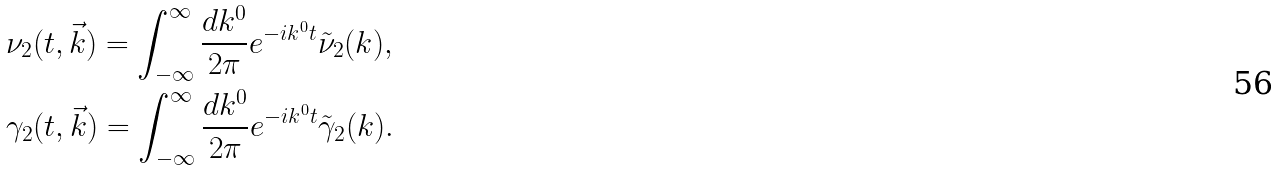Convert formula to latex. <formula><loc_0><loc_0><loc_500><loc_500>& \nu _ { 2 } ( t , \vec { k } ) = \int ^ { \infty } _ { - \infty } \frac { d k ^ { 0 } } { 2 \pi } e ^ { - i k ^ { 0 } t } \tilde { \nu } _ { 2 } ( k ) , \\ & \gamma _ { 2 } ( t , \vec { k } ) = \int ^ { \infty } _ { - \infty } \frac { d k ^ { 0 } } { 2 \pi } e ^ { - i k ^ { 0 } t } \tilde { \gamma } _ { 2 } ( k ) .</formula> 